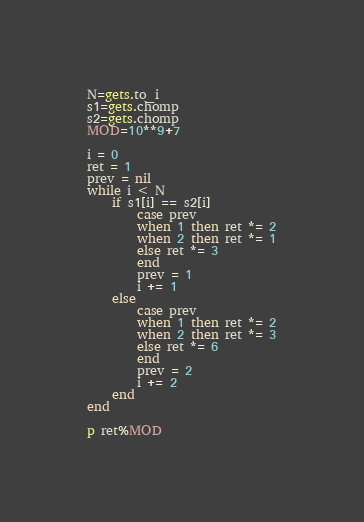<code> <loc_0><loc_0><loc_500><loc_500><_Ruby_>N=gets.to_i
s1=gets.chomp
s2=gets.chomp
MOD=10**9+7

i = 0
ret = 1
prev = nil
while i < N
    if s1[i] == s2[i]
        case prev
        when 1 then ret *= 2
        when 2 then ret *= 1
        else ret *= 3
        end
        prev = 1
        i += 1
    else
        case prev
        when 1 then ret *= 2
        when 2 then ret *= 3
        else ret *= 6
        end
        prev = 2
        i += 2
    end
end

p ret%MOD</code> 